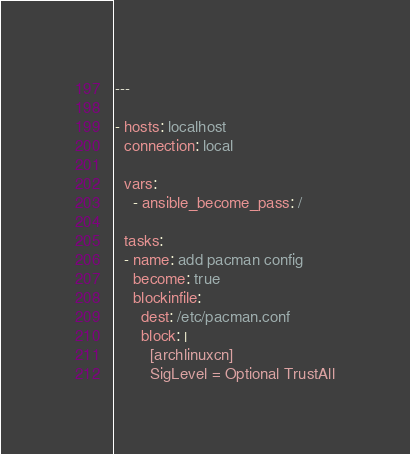<code> <loc_0><loc_0><loc_500><loc_500><_YAML_>---

- hosts: localhost
  connection: local

  vars:
    - ansible_become_pass: /

  tasks:
  - name: add pacman config
    become: true
    blockinfile:
      dest: /etc/pacman.conf
      block: |
        [archlinuxcn]
        SigLevel = Optional TrustAll</code> 